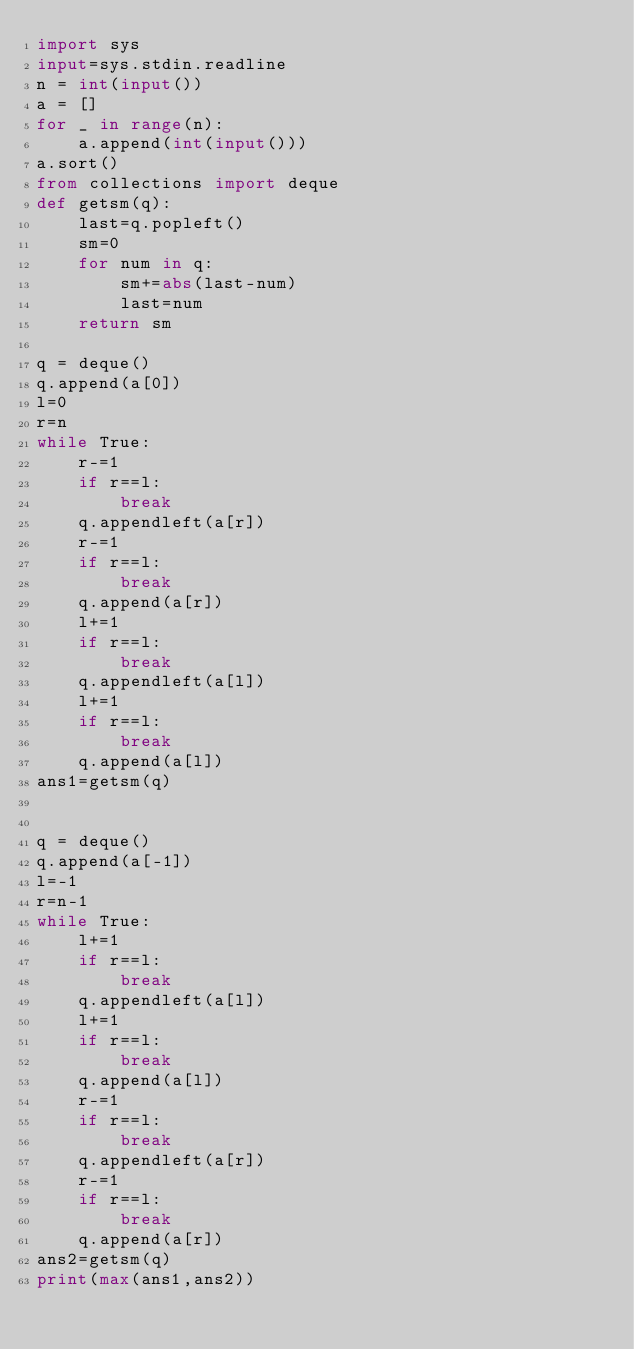<code> <loc_0><loc_0><loc_500><loc_500><_Python_>import sys
input=sys.stdin.readline
n = int(input())
a = []
for _ in range(n):
    a.append(int(input()))
a.sort()
from collections import deque
def getsm(q):
    last=q.popleft()
    sm=0
    for num in q:
        sm+=abs(last-num)
        last=num
    return sm

q = deque()
q.append(a[0])
l=0
r=n
while True:
    r-=1
    if r==l:
        break
    q.appendleft(a[r])
    r-=1
    if r==l:
        break
    q.append(a[r])
    l+=1
    if r==l:
        break
    q.appendleft(a[l])
    l+=1
    if r==l:
        break
    q.append(a[l])
ans1=getsm(q)


q = deque()
q.append(a[-1])
l=-1
r=n-1
while True:
    l+=1
    if r==l:
        break
    q.appendleft(a[l])
    l+=1
    if r==l:
        break
    q.append(a[l])
    r-=1
    if r==l:
        break
    q.appendleft(a[r])
    r-=1
    if r==l:
        break
    q.append(a[r])
ans2=getsm(q)
print(max(ans1,ans2))</code> 